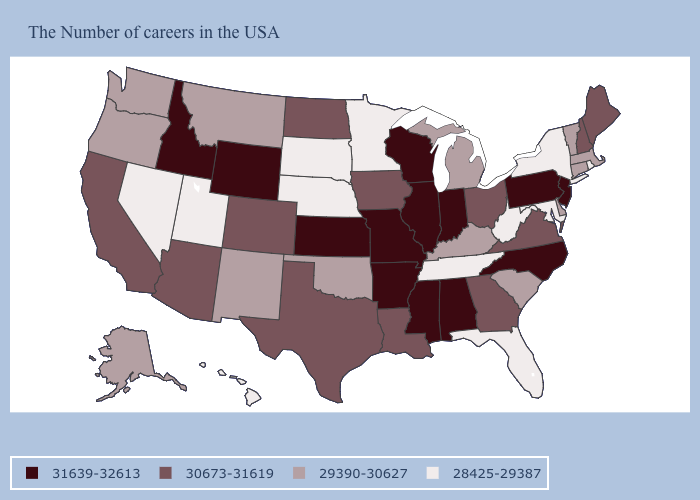What is the value of Arizona?
Answer briefly. 30673-31619. What is the value of Connecticut?
Short answer required. 29390-30627. Does the first symbol in the legend represent the smallest category?
Short answer required. No. What is the value of Maine?
Write a very short answer. 30673-31619. Among the states that border Arkansas , which have the lowest value?
Be succinct. Tennessee. What is the lowest value in the USA?
Short answer required. 28425-29387. What is the highest value in the MidWest ?
Short answer required. 31639-32613. Name the states that have a value in the range 28425-29387?
Short answer required. Rhode Island, New York, Maryland, West Virginia, Florida, Tennessee, Minnesota, Nebraska, South Dakota, Utah, Nevada, Hawaii. Among the states that border Missouri , does Iowa have the lowest value?
Keep it brief. No. Does Ohio have a higher value than Massachusetts?
Keep it brief. Yes. What is the highest value in the West ?
Quick response, please. 31639-32613. What is the value of North Dakota?
Quick response, please. 30673-31619. Does Kansas have the highest value in the USA?
Write a very short answer. Yes. Name the states that have a value in the range 30673-31619?
Give a very brief answer. Maine, New Hampshire, Virginia, Ohio, Georgia, Louisiana, Iowa, Texas, North Dakota, Colorado, Arizona, California. Which states have the lowest value in the USA?
Be succinct. Rhode Island, New York, Maryland, West Virginia, Florida, Tennessee, Minnesota, Nebraska, South Dakota, Utah, Nevada, Hawaii. 